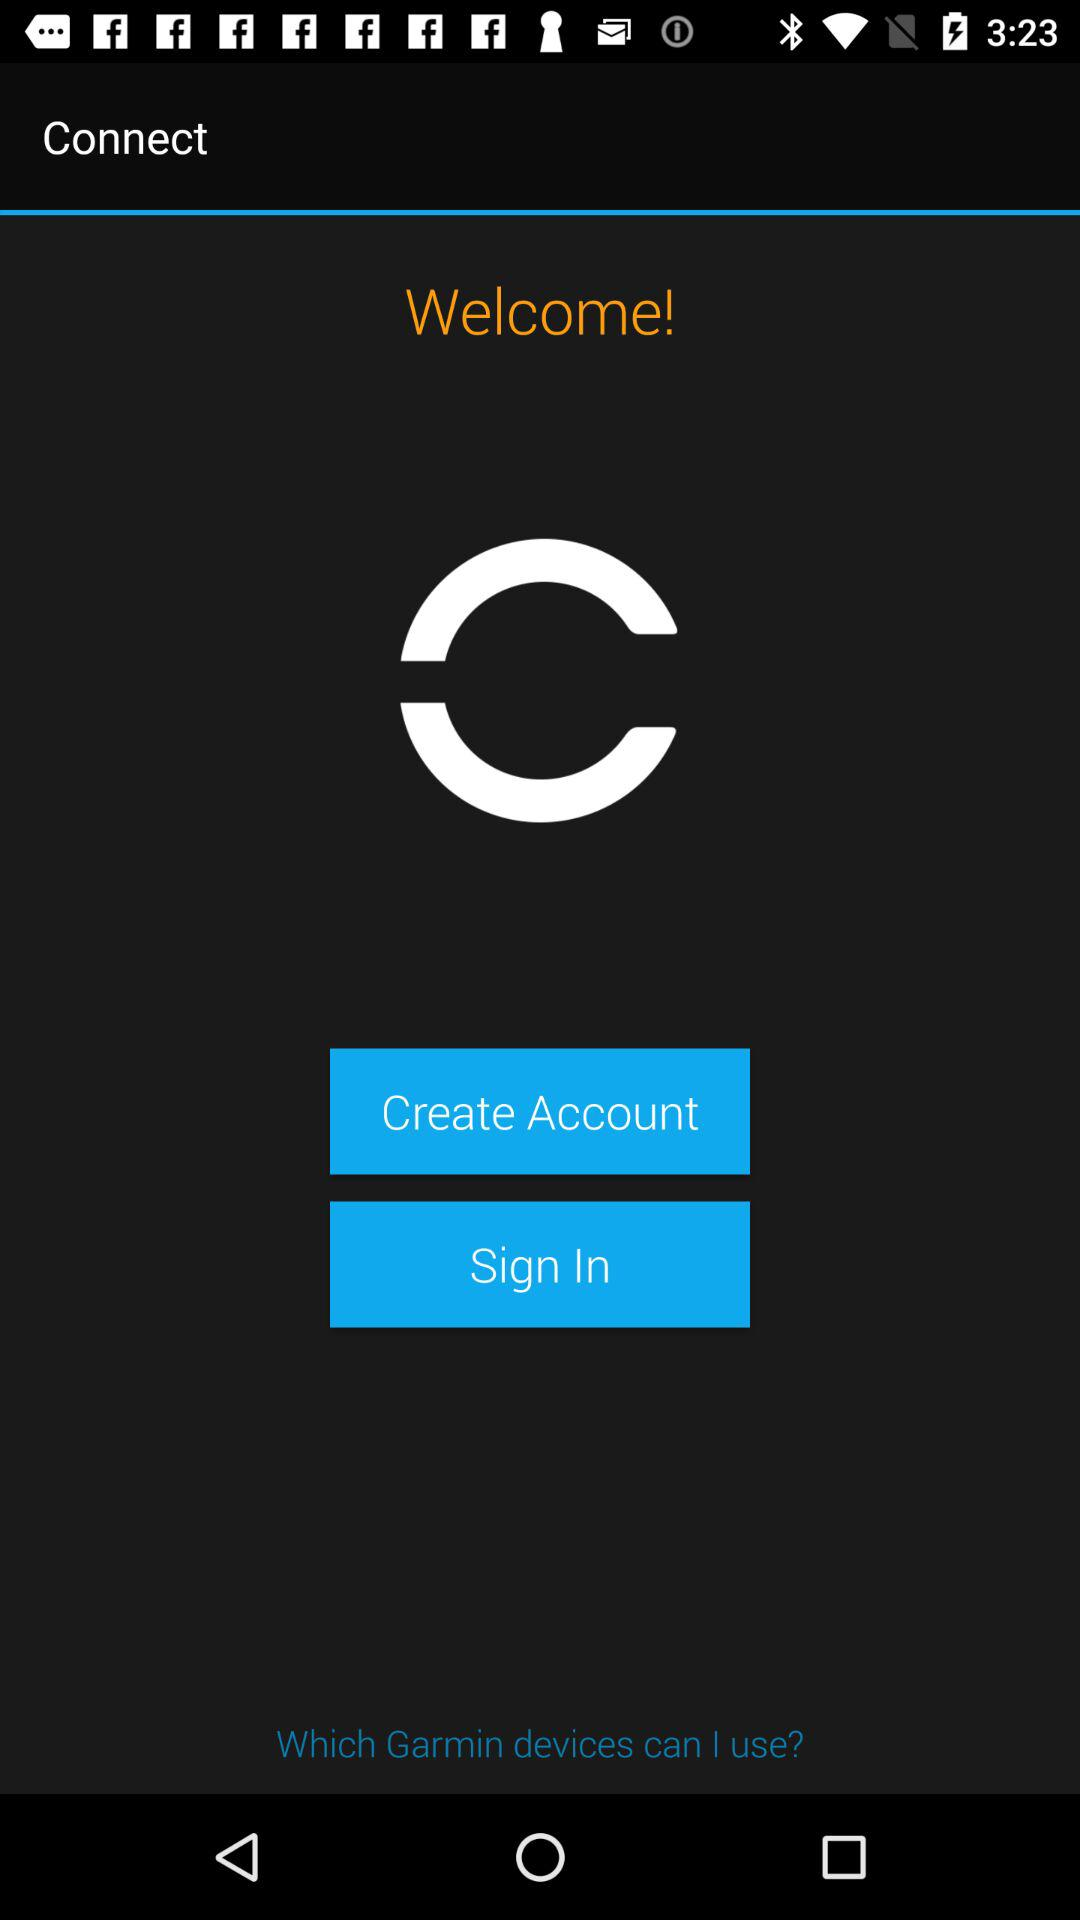What is the name of the application? The name of the application is "Connect". 